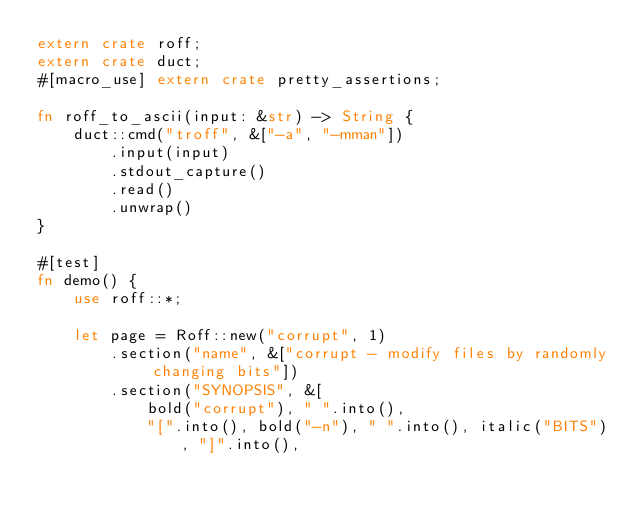<code> <loc_0><loc_0><loc_500><loc_500><_Rust_>extern crate roff;
extern crate duct;
#[macro_use] extern crate pretty_assertions;

fn roff_to_ascii(input: &str) -> String {
    duct::cmd("troff", &["-a", "-mman"])
        .input(input)
        .stdout_capture()
        .read()
        .unwrap()
}

#[test]
fn demo() {
    use roff::*;

    let page = Roff::new("corrupt", 1)
        .section("name", &["corrupt - modify files by randomly changing bits"])
        .section("SYNOPSIS", &[
            bold("corrupt"), " ".into(),
            "[".into(), bold("-n"), " ".into(), italic("BITS"), "]".into(),</code> 